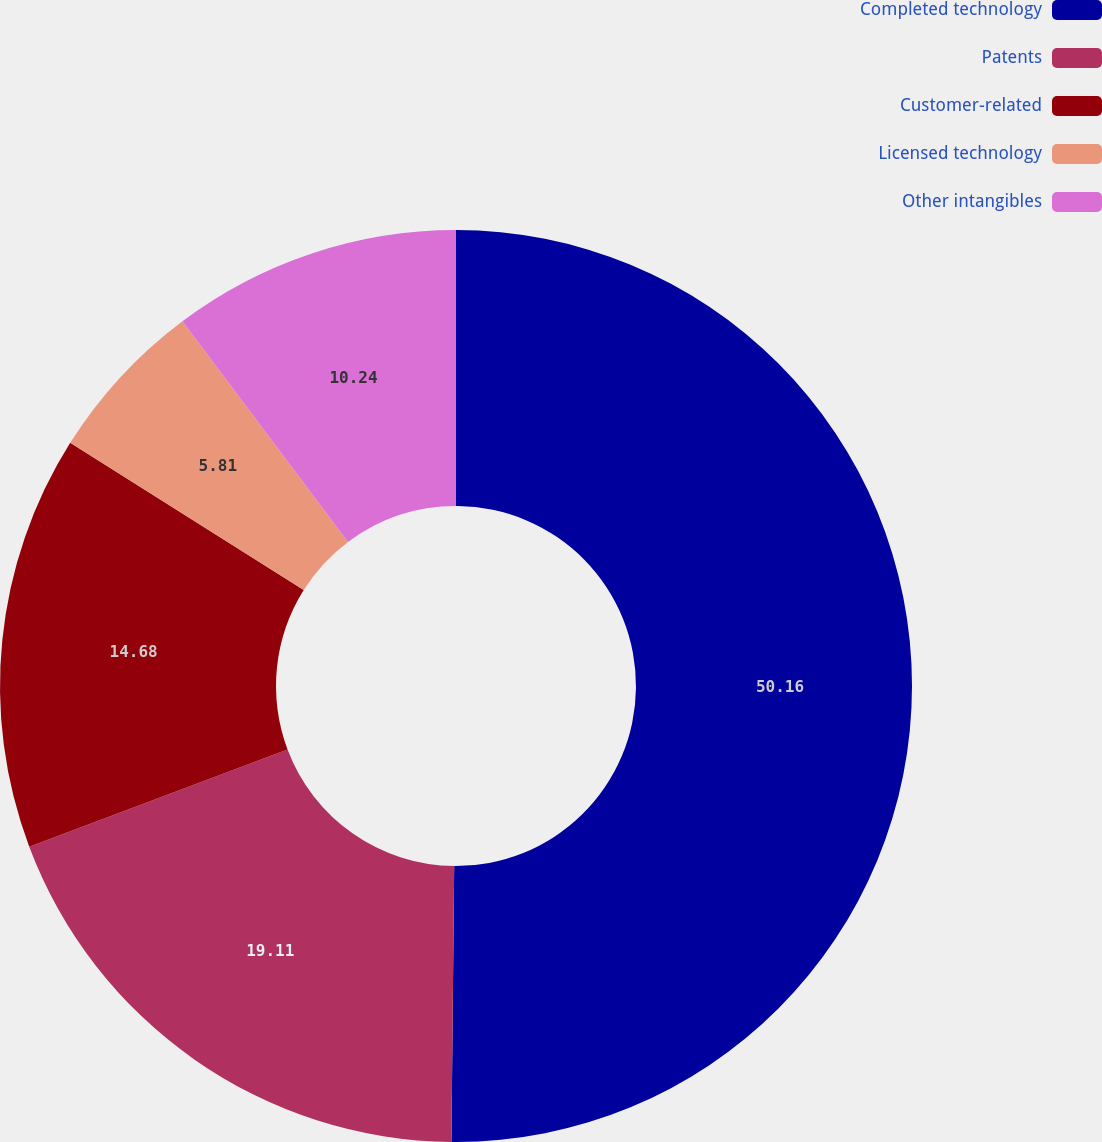<chart> <loc_0><loc_0><loc_500><loc_500><pie_chart><fcel>Completed technology<fcel>Patents<fcel>Customer-related<fcel>Licensed technology<fcel>Other intangibles<nl><fcel>50.16%<fcel>19.11%<fcel>14.68%<fcel>5.81%<fcel>10.24%<nl></chart> 